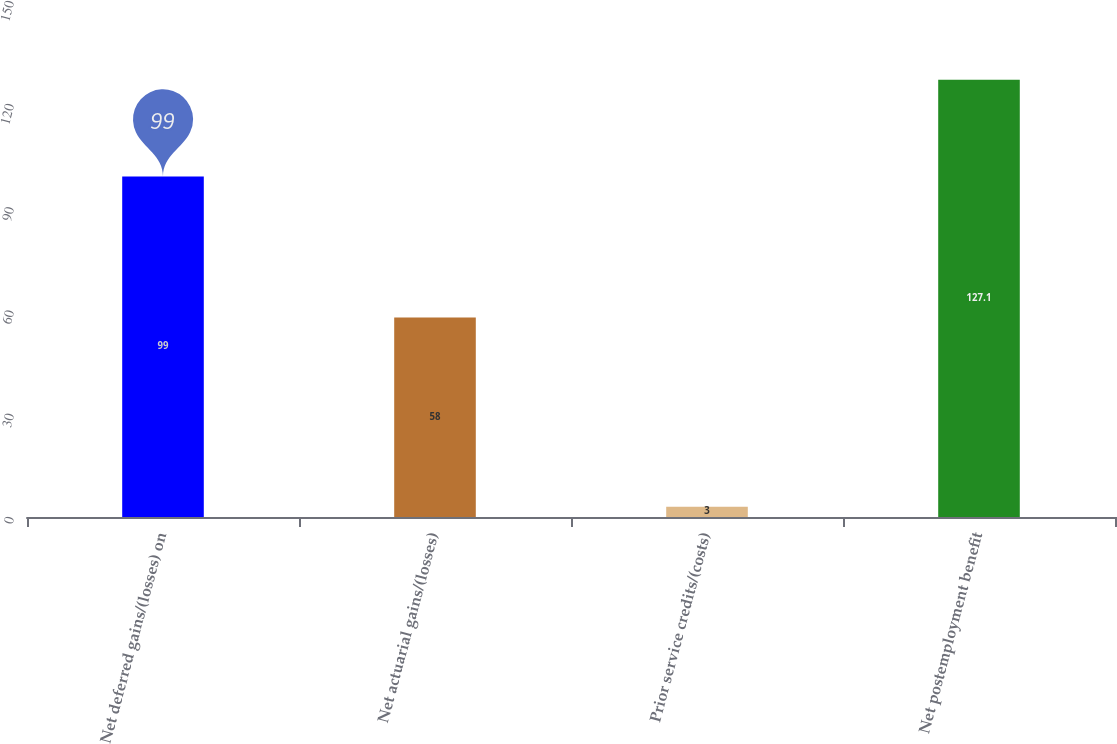<chart> <loc_0><loc_0><loc_500><loc_500><bar_chart><fcel>Net deferred gains/(losses) on<fcel>Net actuarial gains/(losses)<fcel>Prior service credits/(costs)<fcel>Net postemployment benefit<nl><fcel>99<fcel>58<fcel>3<fcel>127.1<nl></chart> 